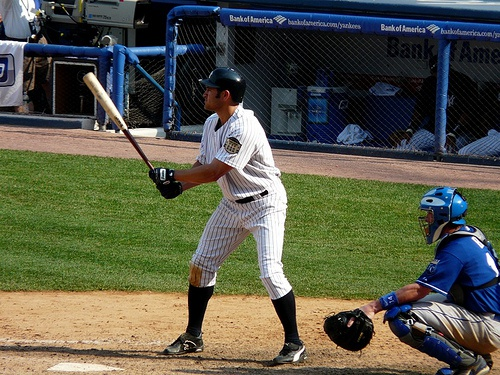Describe the objects in this image and their specific colors. I can see people in gray, black, white, and darkgray tones, people in gray, black, navy, and blue tones, people in gray, black, navy, and darkblue tones, people in gray and black tones, and baseball glove in gray, black, maroon, and tan tones in this image. 